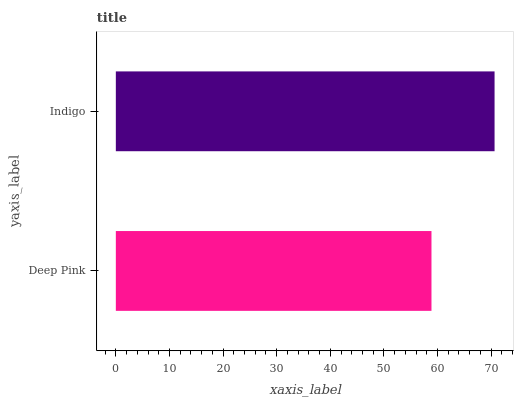Is Deep Pink the minimum?
Answer yes or no. Yes. Is Indigo the maximum?
Answer yes or no. Yes. Is Indigo the minimum?
Answer yes or no. No. Is Indigo greater than Deep Pink?
Answer yes or no. Yes. Is Deep Pink less than Indigo?
Answer yes or no. Yes. Is Deep Pink greater than Indigo?
Answer yes or no. No. Is Indigo less than Deep Pink?
Answer yes or no. No. Is Indigo the high median?
Answer yes or no. Yes. Is Deep Pink the low median?
Answer yes or no. Yes. Is Deep Pink the high median?
Answer yes or no. No. Is Indigo the low median?
Answer yes or no. No. 